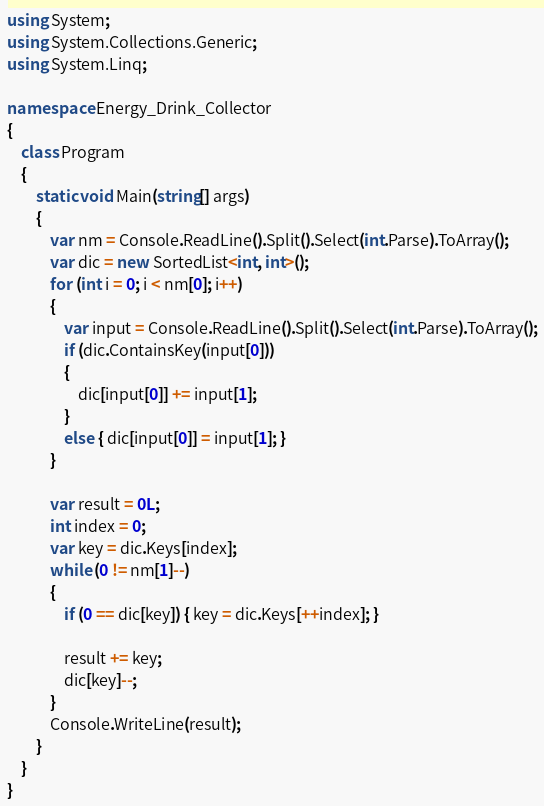<code> <loc_0><loc_0><loc_500><loc_500><_C#_>using System;
using System.Collections.Generic;
using System.Linq;

namespace Energy_Drink_Collector
{
    class Program
    {
        static void Main(string[] args)
        {
            var nm = Console.ReadLine().Split().Select(int.Parse).ToArray();
            var dic = new SortedList<int, int>();
            for (int i = 0; i < nm[0]; i++)
            {
                var input = Console.ReadLine().Split().Select(int.Parse).ToArray();
                if (dic.ContainsKey(input[0]))
                {
                    dic[input[0]] += input[1];
                }
                else { dic[input[0]] = input[1]; }
            }

            var result = 0L;
            int index = 0;
            var key = dic.Keys[index];
            while (0 != nm[1]--)
            {
                if (0 == dic[key]) { key = dic.Keys[++index]; }

                result += key;
                dic[key]--;
            }
            Console.WriteLine(result);
        }
    }
}
</code> 